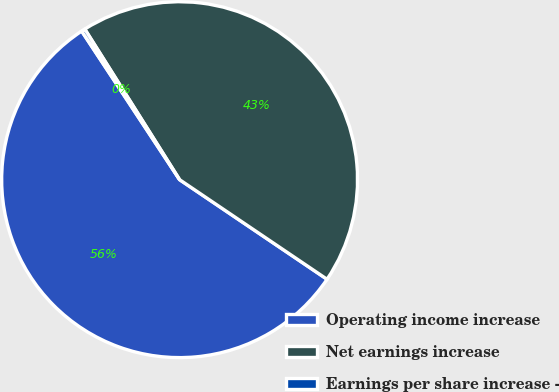Convert chart to OTSL. <chart><loc_0><loc_0><loc_500><loc_500><pie_chart><fcel>Operating income increase<fcel>Net earnings increase<fcel>Earnings per share increase -<nl><fcel>56.27%<fcel>43.4%<fcel>0.33%<nl></chart> 